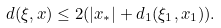<formula> <loc_0><loc_0><loc_500><loc_500>d ( \xi , x ) \leq 2 ( | x _ { * } | + d _ { 1 } ( \xi _ { 1 } , x _ { 1 } ) ) .</formula> 